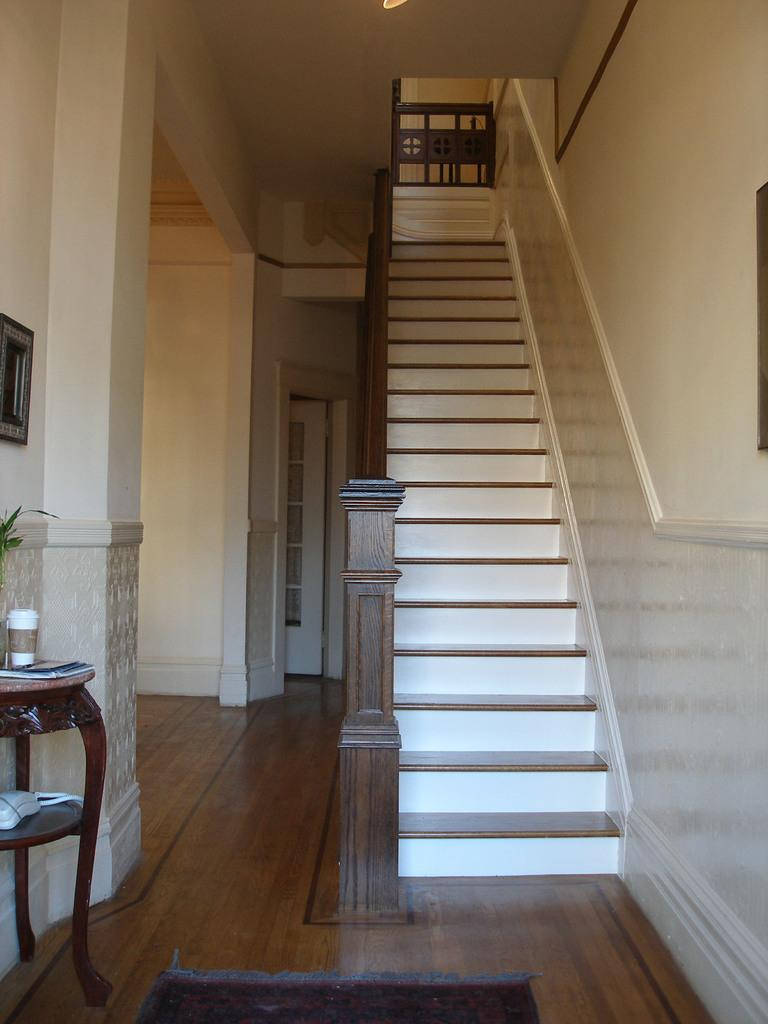What type of architectural feature is present in the image? There is a staircase in the image. What safety feature is present alongside the staircase? There is a railing in the image. What is placed near the entrance of the area in the image? There is a doormat in the image. What piece of furniture can be seen in the image? There is a side table in the image. What type of decorative item is present on the wall in the image? There is a wall hanging in the image. What structural elements support the ceiling in the image? There are pillars in the image. What type of access point is present in the image? There are doors in the image. How many knees can be seen supporting the weight of the person in the image? There are no people visible in the image, so it is not possible to determine the number of knees present. 